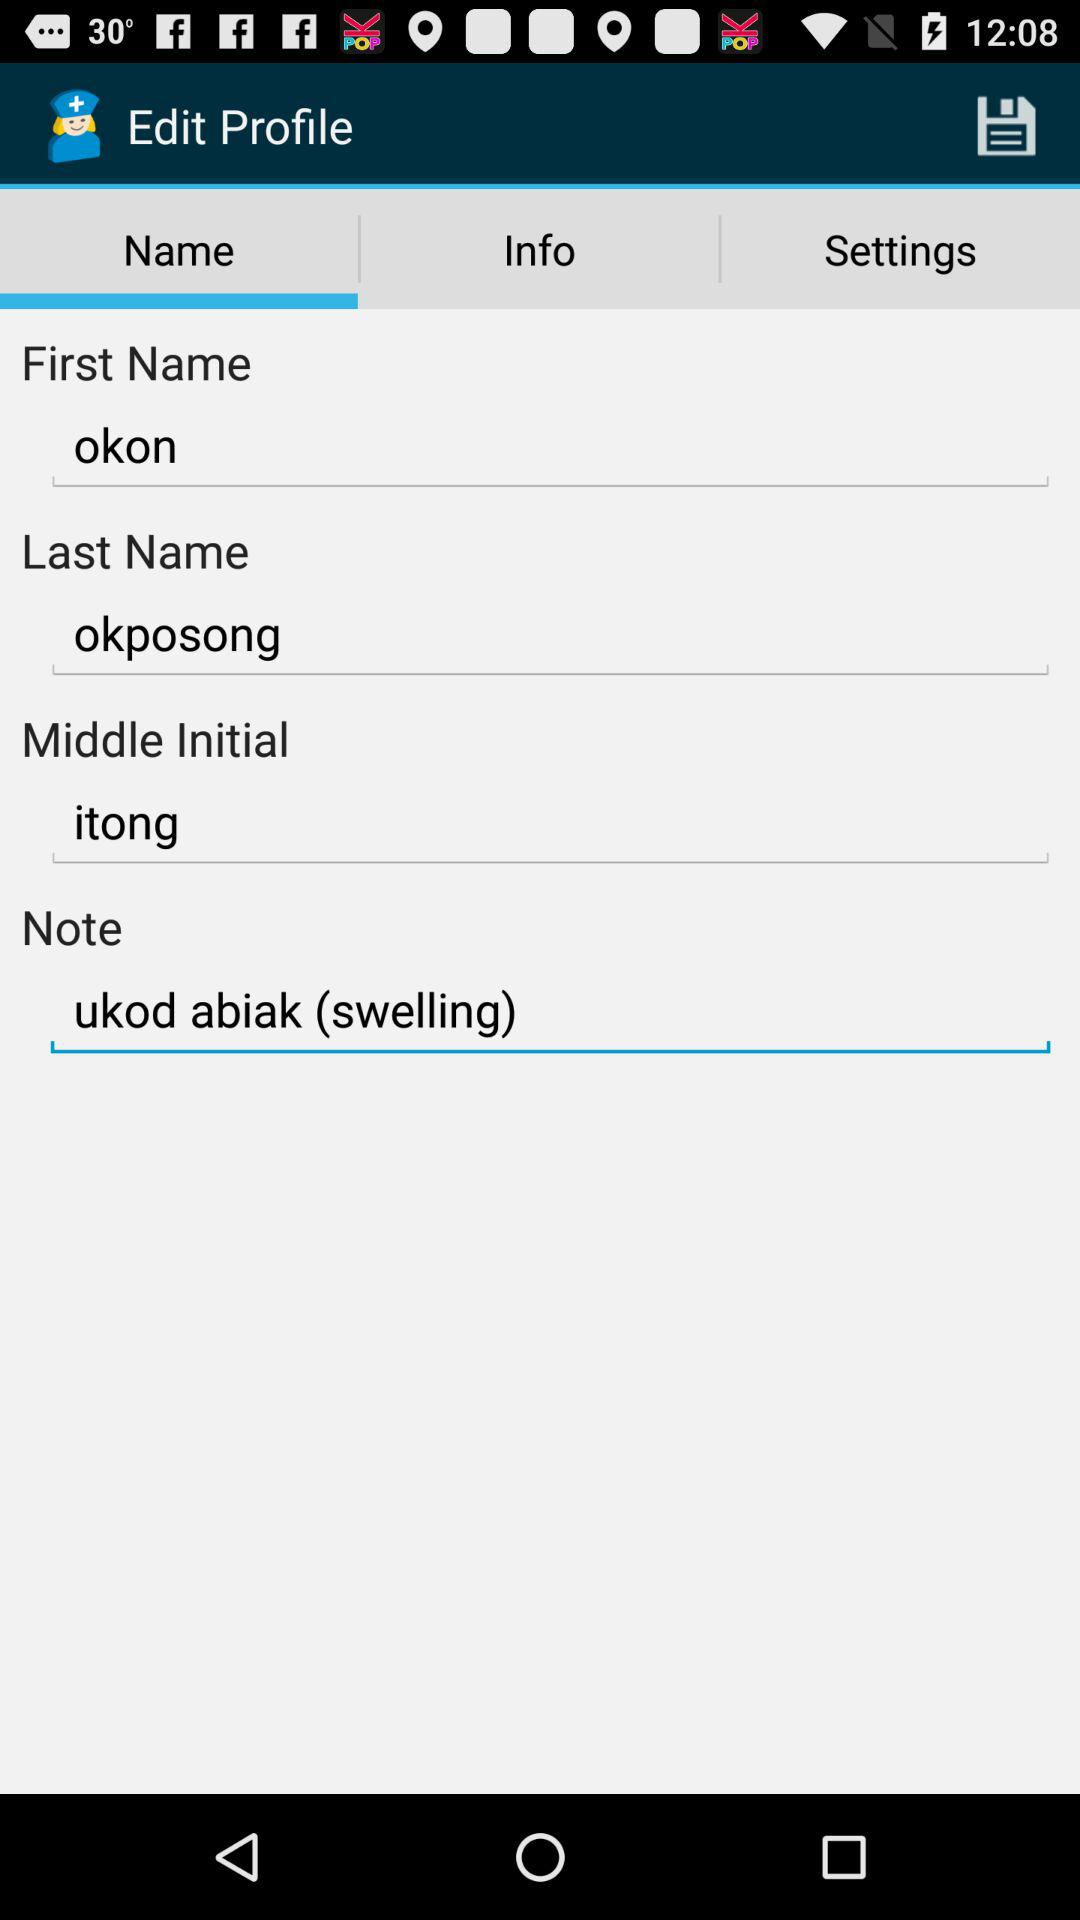What is the user's middle initial? The user's middle initial is Itong. 